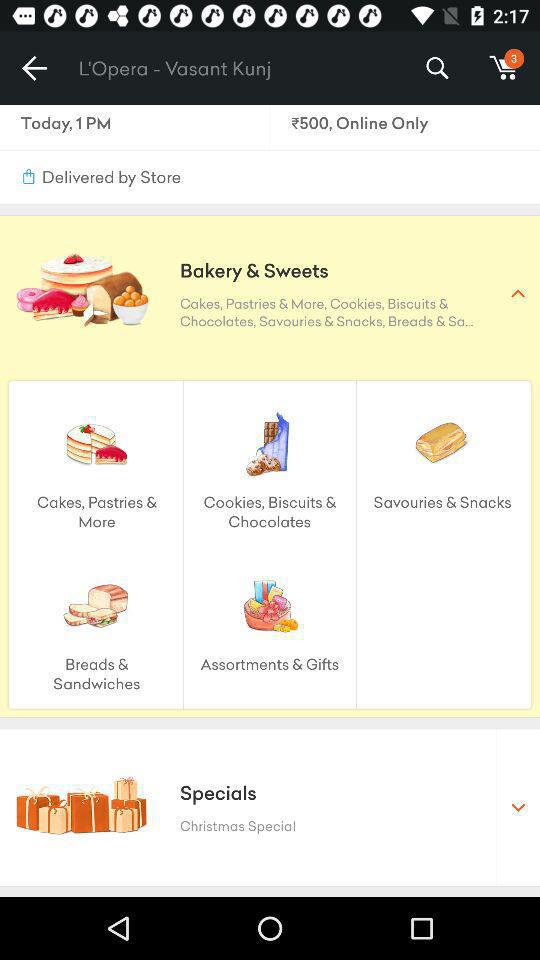What is the price of Bakery % Sweets?
When the provided information is insufficient, respond with <no answer>. <no answer> 